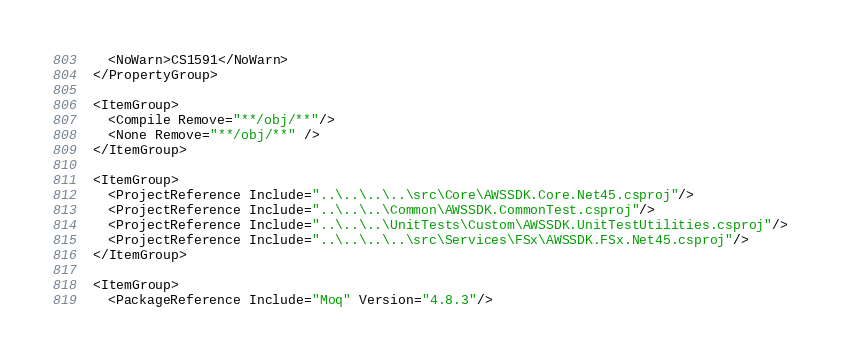Convert code to text. <code><loc_0><loc_0><loc_500><loc_500><_XML_>
    <NoWarn>CS1591</NoWarn>
  </PropertyGroup>

  <ItemGroup>
    <Compile Remove="**/obj/**"/>
    <None Remove="**/obj/**" />
  </ItemGroup>

  <ItemGroup>
    <ProjectReference Include="..\..\..\..\src\Core\AWSSDK.Core.Net45.csproj"/>
    <ProjectReference Include="..\..\..\Common\AWSSDK.CommonTest.csproj"/>
    <ProjectReference Include="..\..\..\UnitTests\Custom\AWSSDK.UnitTestUtilities.csproj"/>
    <ProjectReference Include="..\..\..\..\src\Services\FSx\AWSSDK.FSx.Net45.csproj"/>
  </ItemGroup>

  <ItemGroup>
    <PackageReference Include="Moq" Version="4.8.3"/></code> 